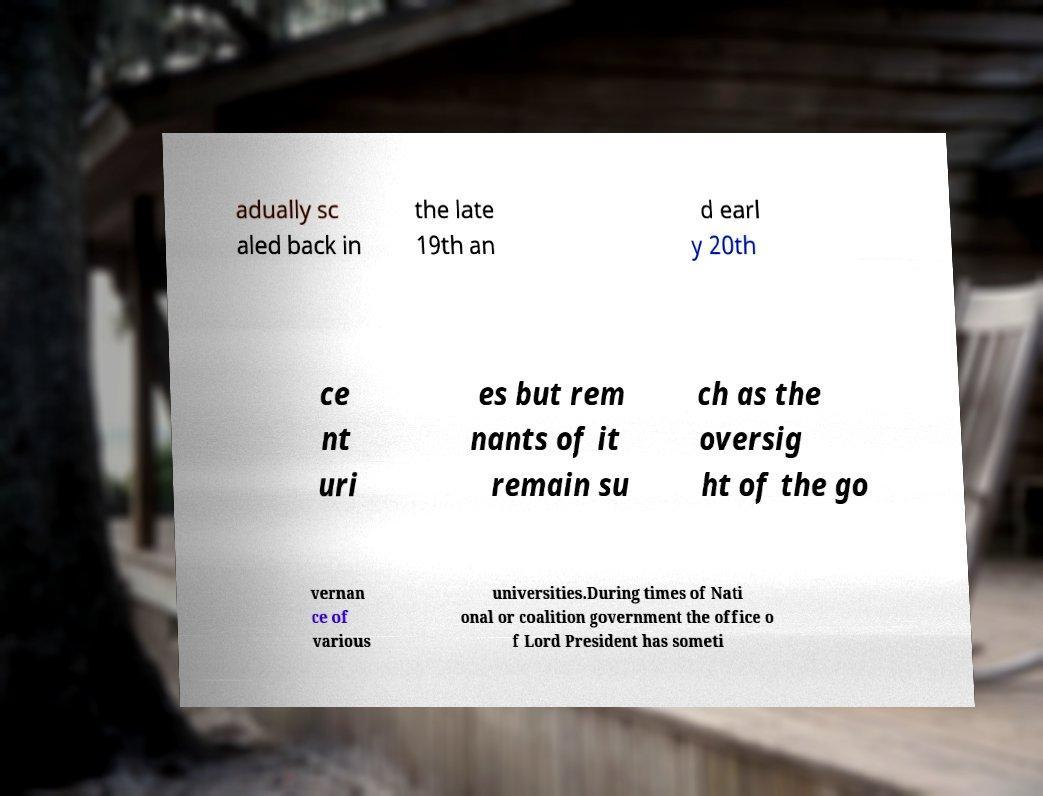I need the written content from this picture converted into text. Can you do that? adually sc aled back in the late 19th an d earl y 20th ce nt uri es but rem nants of it remain su ch as the oversig ht of the go vernan ce of various universities.During times of Nati onal or coalition government the office o f Lord President has someti 